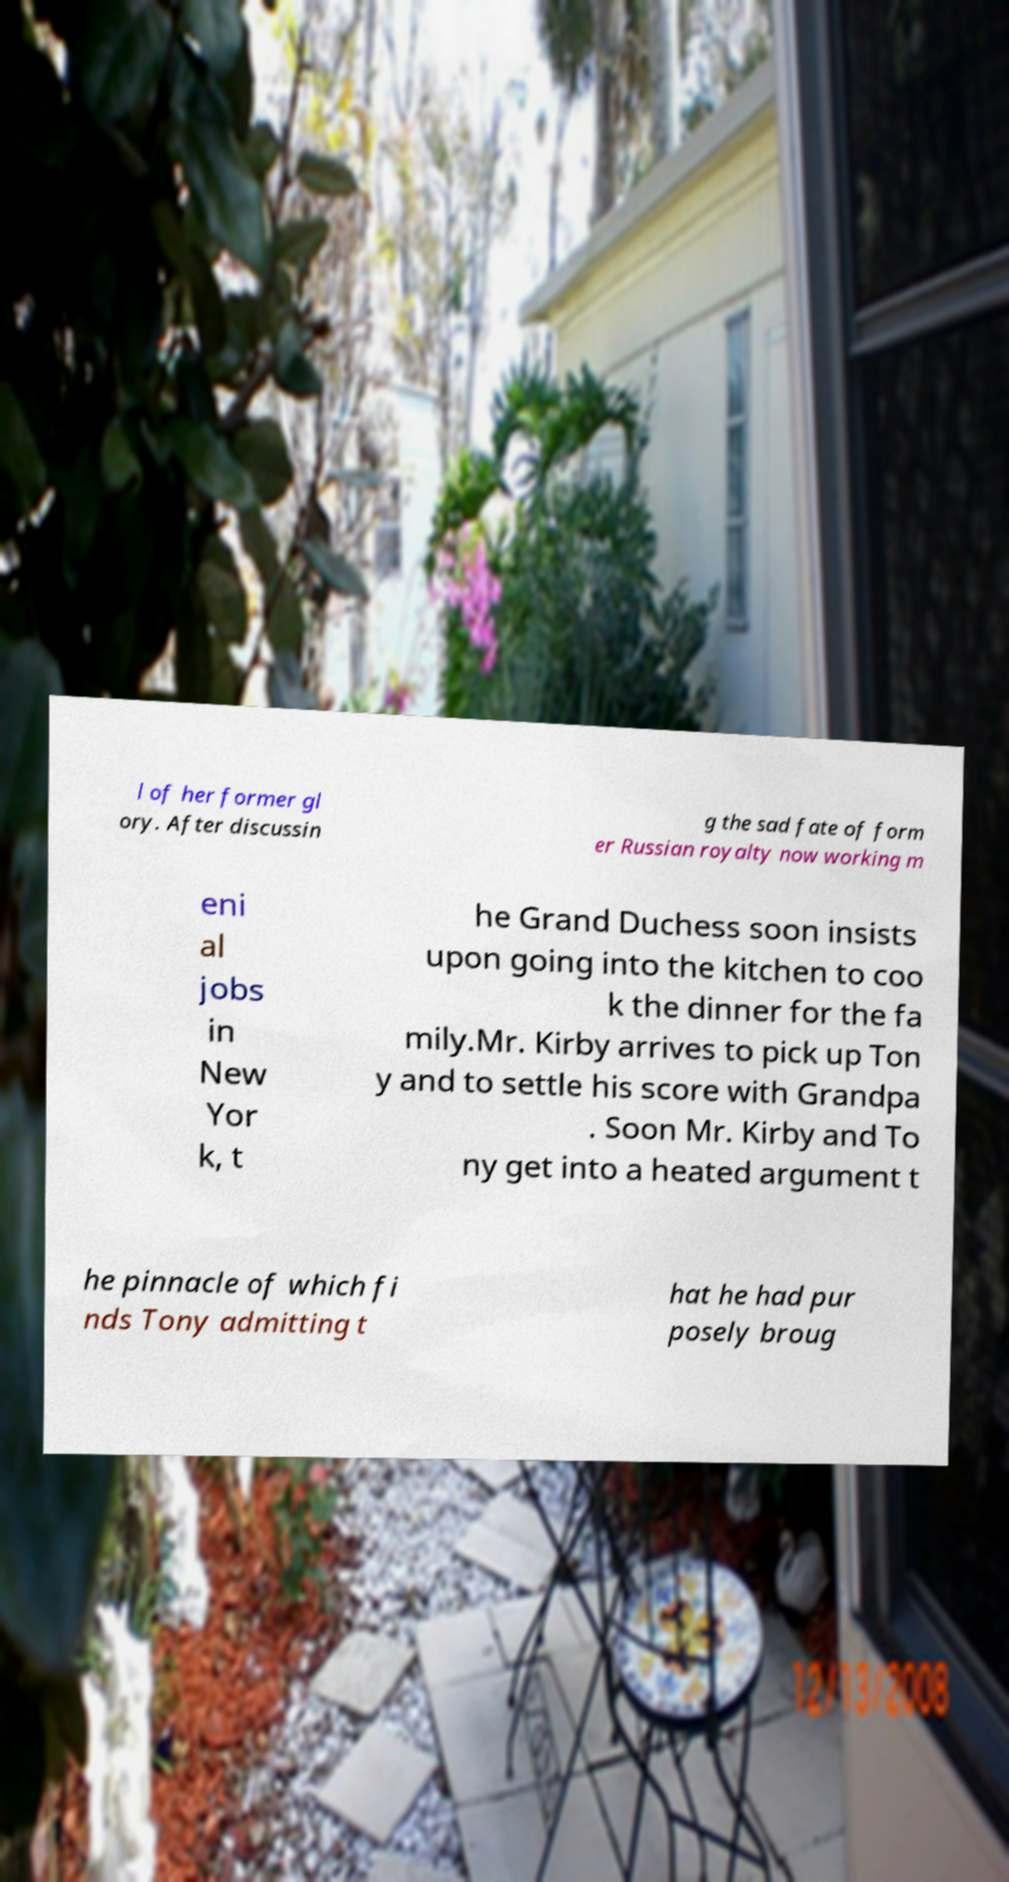For documentation purposes, I need the text within this image transcribed. Could you provide that? l of her former gl ory. After discussin g the sad fate of form er Russian royalty now working m eni al jobs in New Yor k, t he Grand Duchess soon insists upon going into the kitchen to coo k the dinner for the fa mily.Mr. Kirby arrives to pick up Ton y and to settle his score with Grandpa . Soon Mr. Kirby and To ny get into a heated argument t he pinnacle of which fi nds Tony admitting t hat he had pur posely broug 